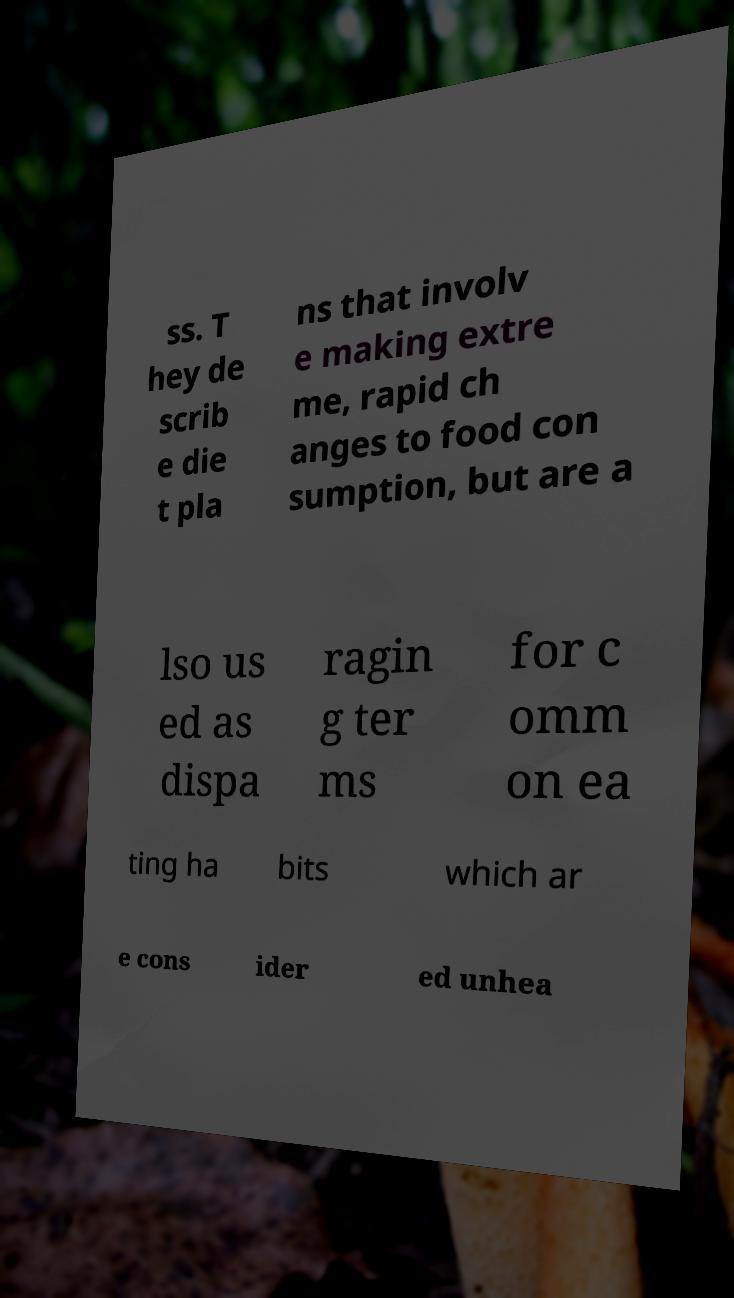What messages or text are displayed in this image? I need them in a readable, typed format. ss. T hey de scrib e die t pla ns that involv e making extre me, rapid ch anges to food con sumption, but are a lso us ed as dispa ragin g ter ms for c omm on ea ting ha bits which ar e cons ider ed unhea 